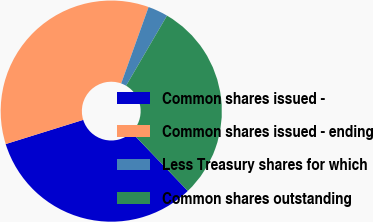<chart> <loc_0><loc_0><loc_500><loc_500><pie_chart><fcel>Common shares issued -<fcel>Common shares issued - ending<fcel>Less Treasury shares for which<fcel>Common shares outstanding<nl><fcel>32.36%<fcel>35.3%<fcel>2.93%<fcel>29.42%<nl></chart> 